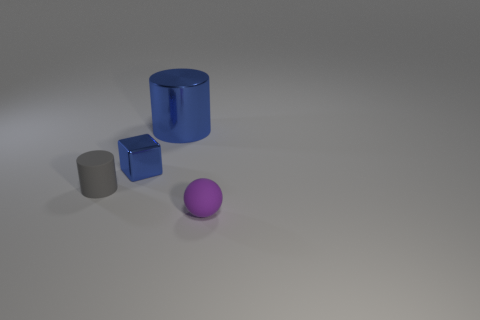Is there another matte ball of the same color as the sphere?
Your response must be concise. No. The ball that is the same size as the gray cylinder is what color?
Provide a succinct answer. Purple. Do the big blue thing and the small purple matte object have the same shape?
Give a very brief answer. No. There is a cylinder that is to the right of the gray cylinder; what material is it?
Your answer should be compact. Metal. What color is the tiny cylinder?
Offer a terse response. Gray. There is a cylinder that is in front of the big metallic cylinder; is it the same size as the cylinder behind the small cylinder?
Provide a short and direct response. No. There is a thing that is both in front of the blue shiny cube and on the left side of the small purple object; what size is it?
Offer a terse response. Small. What is the color of the other large shiny object that is the same shape as the gray object?
Give a very brief answer. Blue. Are there more small rubber balls that are left of the metal cylinder than tiny matte balls that are to the left of the ball?
Offer a very short reply. No. How many other objects are the same shape as the small purple thing?
Provide a short and direct response. 0. 